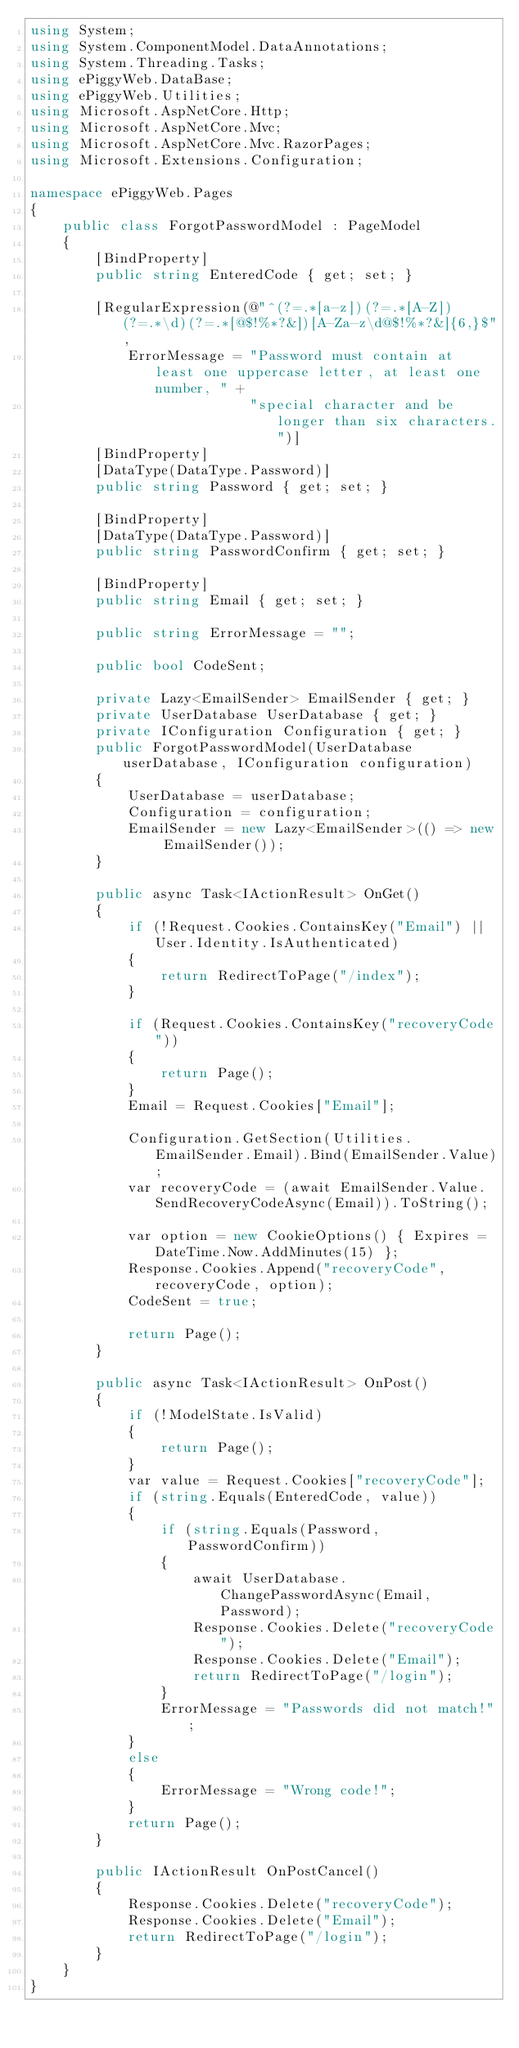<code> <loc_0><loc_0><loc_500><loc_500><_C#_>using System;
using System.ComponentModel.DataAnnotations;
using System.Threading.Tasks;
using ePiggyWeb.DataBase;
using ePiggyWeb.Utilities;
using Microsoft.AspNetCore.Http;
using Microsoft.AspNetCore.Mvc;
using Microsoft.AspNetCore.Mvc.RazorPages;
using Microsoft.Extensions.Configuration;

namespace ePiggyWeb.Pages
{
    public class ForgotPasswordModel : PageModel
    {
        [BindProperty]
        public string EnteredCode { get; set; }

        [RegularExpression(@"^(?=.*[a-z])(?=.*[A-Z])(?=.*\d)(?=.*[@$!%*?&])[A-Za-z\d@$!%*?&]{6,}$", 
            ErrorMessage = "Password must contain at least one uppercase letter, at least one number, " +
                           "special character and be longer than six characters.")]
        [BindProperty]
        [DataType(DataType.Password)]
        public string Password { get; set; }

        [BindProperty]
        [DataType(DataType.Password)]
        public string PasswordConfirm { get; set; }

        [BindProperty]
        public string Email { get; set; }

        public string ErrorMessage = "";

        public bool CodeSent;

        private Lazy<EmailSender> EmailSender { get; }
        private UserDatabase UserDatabase { get; }
        private IConfiguration Configuration { get; }
        public ForgotPasswordModel(UserDatabase userDatabase, IConfiguration configuration)
        {
            UserDatabase = userDatabase;
            Configuration = configuration;
            EmailSender = new Lazy<EmailSender>(() => new EmailSender());
        }

        public async Task<IActionResult> OnGet()
        {
            if (!Request.Cookies.ContainsKey("Email") || User.Identity.IsAuthenticated)
            {
                return RedirectToPage("/index");
            }

            if (Request.Cookies.ContainsKey("recoveryCode"))
            {
                return Page();
            }
            Email = Request.Cookies["Email"];

            Configuration.GetSection(Utilities.EmailSender.Email).Bind(EmailSender.Value);
            var recoveryCode = (await EmailSender.Value.SendRecoveryCodeAsync(Email)).ToString();

            var option = new CookieOptions() { Expires = DateTime.Now.AddMinutes(15) };
            Response.Cookies.Append("recoveryCode", recoveryCode, option);
            CodeSent = true;

            return Page();
        }

        public async Task<IActionResult> OnPost()
        {
            if (!ModelState.IsValid)
            {
                return Page();
            }
            var value = Request.Cookies["recoveryCode"];
            if (string.Equals(EnteredCode, value))
            {
                if (string.Equals(Password, PasswordConfirm))
                {
                    await UserDatabase.ChangePasswordAsync(Email, Password);
                    Response.Cookies.Delete("recoveryCode");
                    Response.Cookies.Delete("Email");
                    return RedirectToPage("/login");
                }
                ErrorMessage = "Passwords did not match!";
            }
            else
            {
                ErrorMessage = "Wrong code!";
            }
            return Page();
        }

        public IActionResult OnPostCancel()
        {
            Response.Cookies.Delete("recoveryCode");
            Response.Cookies.Delete("Email");
            return RedirectToPage("/login");
        }
    }
}
</code> 